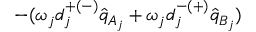Convert formula to latex. <formula><loc_0><loc_0><loc_500><loc_500>- ( \omega _ { j } d _ { j } ^ { + ( - ) } \hat { q } _ { A _ { j } } + \omega _ { j } d _ { j } ^ { - ( + ) } \hat { q } _ { B _ { j } } )</formula> 